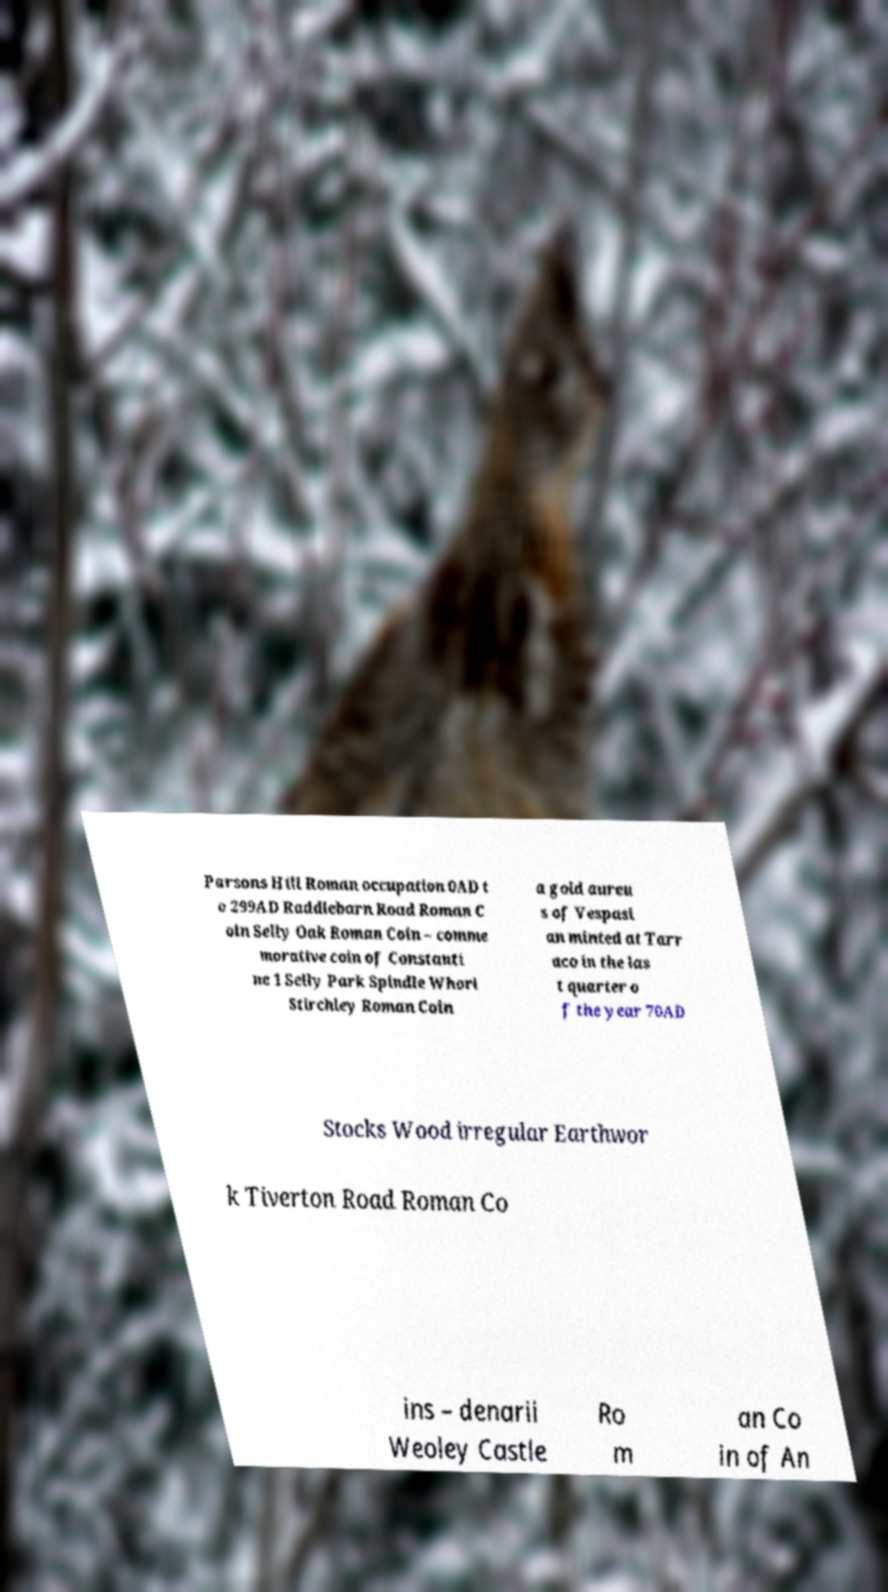Can you read and provide the text displayed in the image?This photo seems to have some interesting text. Can you extract and type it out for me? Parsons Hill Roman occupation 0AD t o 299AD Raddlebarn Road Roman C oin Selly Oak Roman Coin – comme morative coin of Constanti ne 1 Selly Park Spindle Whorl Stirchley Roman Coin a gold aureu s of Vespasi an minted at Tarr aco in the las t quarter o f the year 70AD Stocks Wood irregular Earthwor k Tiverton Road Roman Co ins – denarii Weoley Castle Ro m an Co in of An 